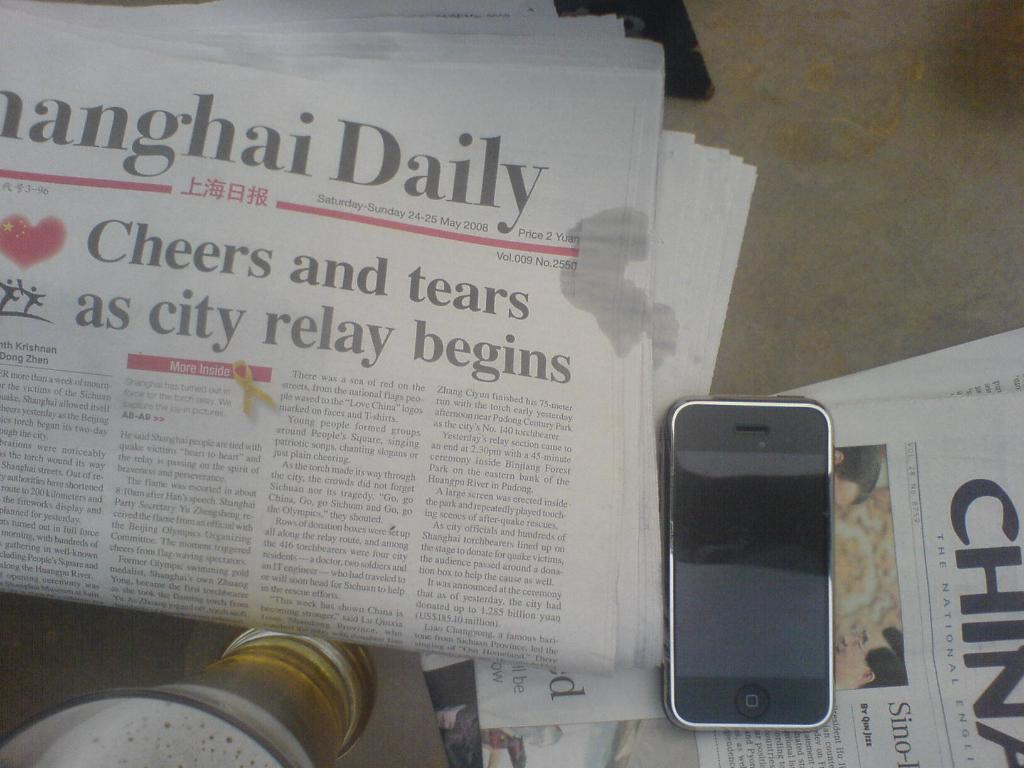<image>
Summarize the visual content of the image. Newspaper article on top of a table titled "Shanghai Daily". 